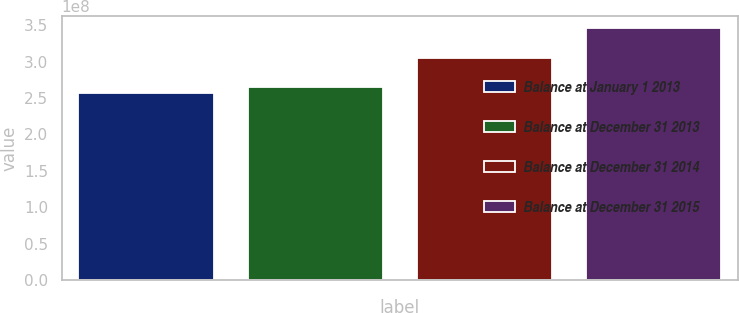<chart> <loc_0><loc_0><loc_500><loc_500><bar_chart><fcel>Balance at January 1 2013<fcel>Balance at December 31 2013<fcel>Balance at December 31 2014<fcel>Balance at December 31 2015<nl><fcel>2.56631e+08<fcel>2.65531e+08<fcel>3.05534e+08<fcel>3.45637e+08<nl></chart> 